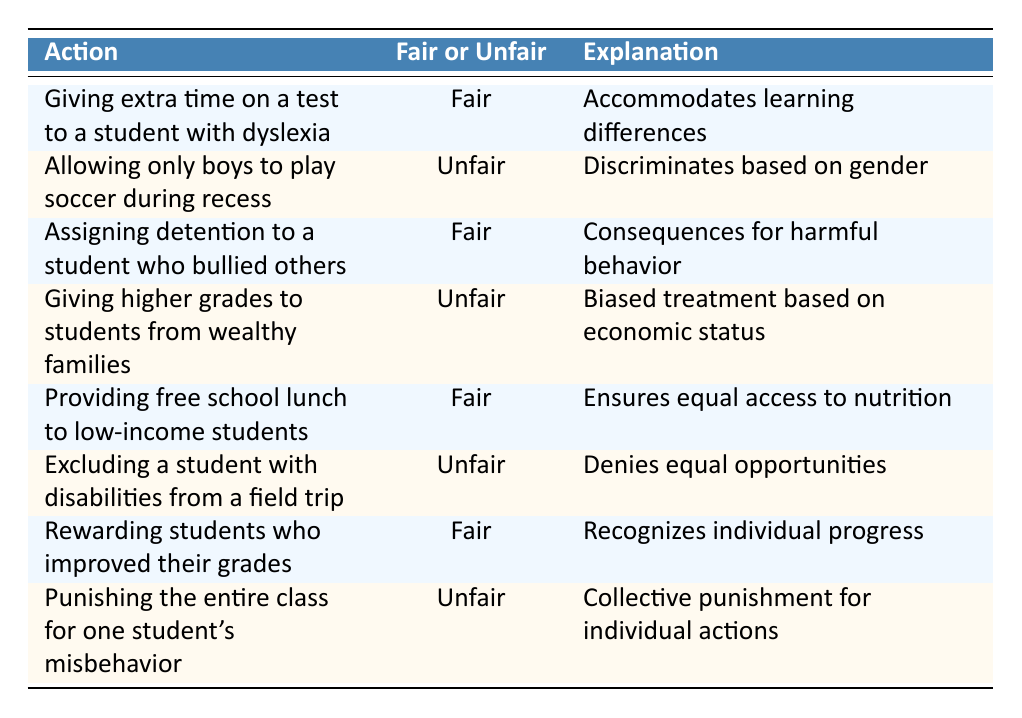What action is labeled as "Unfair" that involves gender discrimination? The table shows that "Allowing only boys to play soccer during recess" is labeled as "Unfair" because it discriminates based on gender.
Answer: Allowing only boys to play soccer during recess How many actions in the table are categorized as "Fair"? There are 4 actions labeled as "Fair" in the table: Giving extra time on a test to a student with dyslexia, Assigning detention to a student who bullied others, Providing free school lunch to low-income students, and Rewarding students who improved their grades.
Answer: 4 Is giving higher grades to students from wealthy families considered "Fair"? The table indicates that giving higher grades to students from wealthy families is labeled as "Unfair" due to biased treatment based on economic status.
Answer: No What is the explanation for providing free school lunch to low-income students? The table states that providing free school lunch to low-income students is "Fair" because it ensures equal access to nutrition.
Answer: Ensures equal access to nutrition Identify the action that has collective punishment as its explanation and state whether it is Fair or Unfair. The action "Punishing the entire class for one student's misbehavior" is labeled as "Unfair" because it involves collective punishment for an individual action.
Answer: Unfair List all actions which are considered "Fair" and provide the reasons. The "Fair" actions are: 1. Giving extra time on a test to a student with dyslexia: accommodates learning differences; 2. Assigning detention to a student who bullied others: consequences for harmful behavior; 3. Providing free school lunch to low-income students: ensures equal access to nutrition; 4. Rewarding students who improved their grades: recognizes individual progress.
Answer: Giving extra time for dyslexia, detention for bullying, free lunch for low-income, rewarding grade improvement Which action denies equal opportunities and is marked "Unfair"? The action "Excluding a student with disabilities from a field trip" denies equal opportunities and is labeled as "Unfair" in the table.
Answer: Excluding a student with disabilities from a field trip What can be concluded about the fairness of rewarding students based on academic improvement? Rewarding students who improved their grades is labeled as "Fair" in the table, and is justified through the reasoning that it recognizes individual progress.
Answer: Fair 